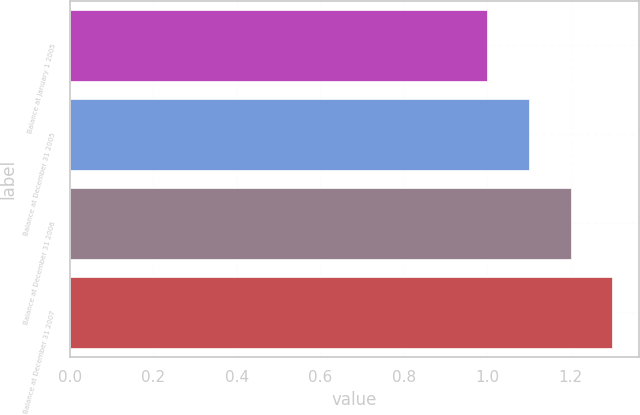Convert chart. <chart><loc_0><loc_0><loc_500><loc_500><bar_chart><fcel>Balance at January 1 2005<fcel>Balance at December 31 2005<fcel>Balance at December 31 2006<fcel>Balance at December 31 2007<nl><fcel>1<fcel>1.1<fcel>1.2<fcel>1.3<nl></chart> 